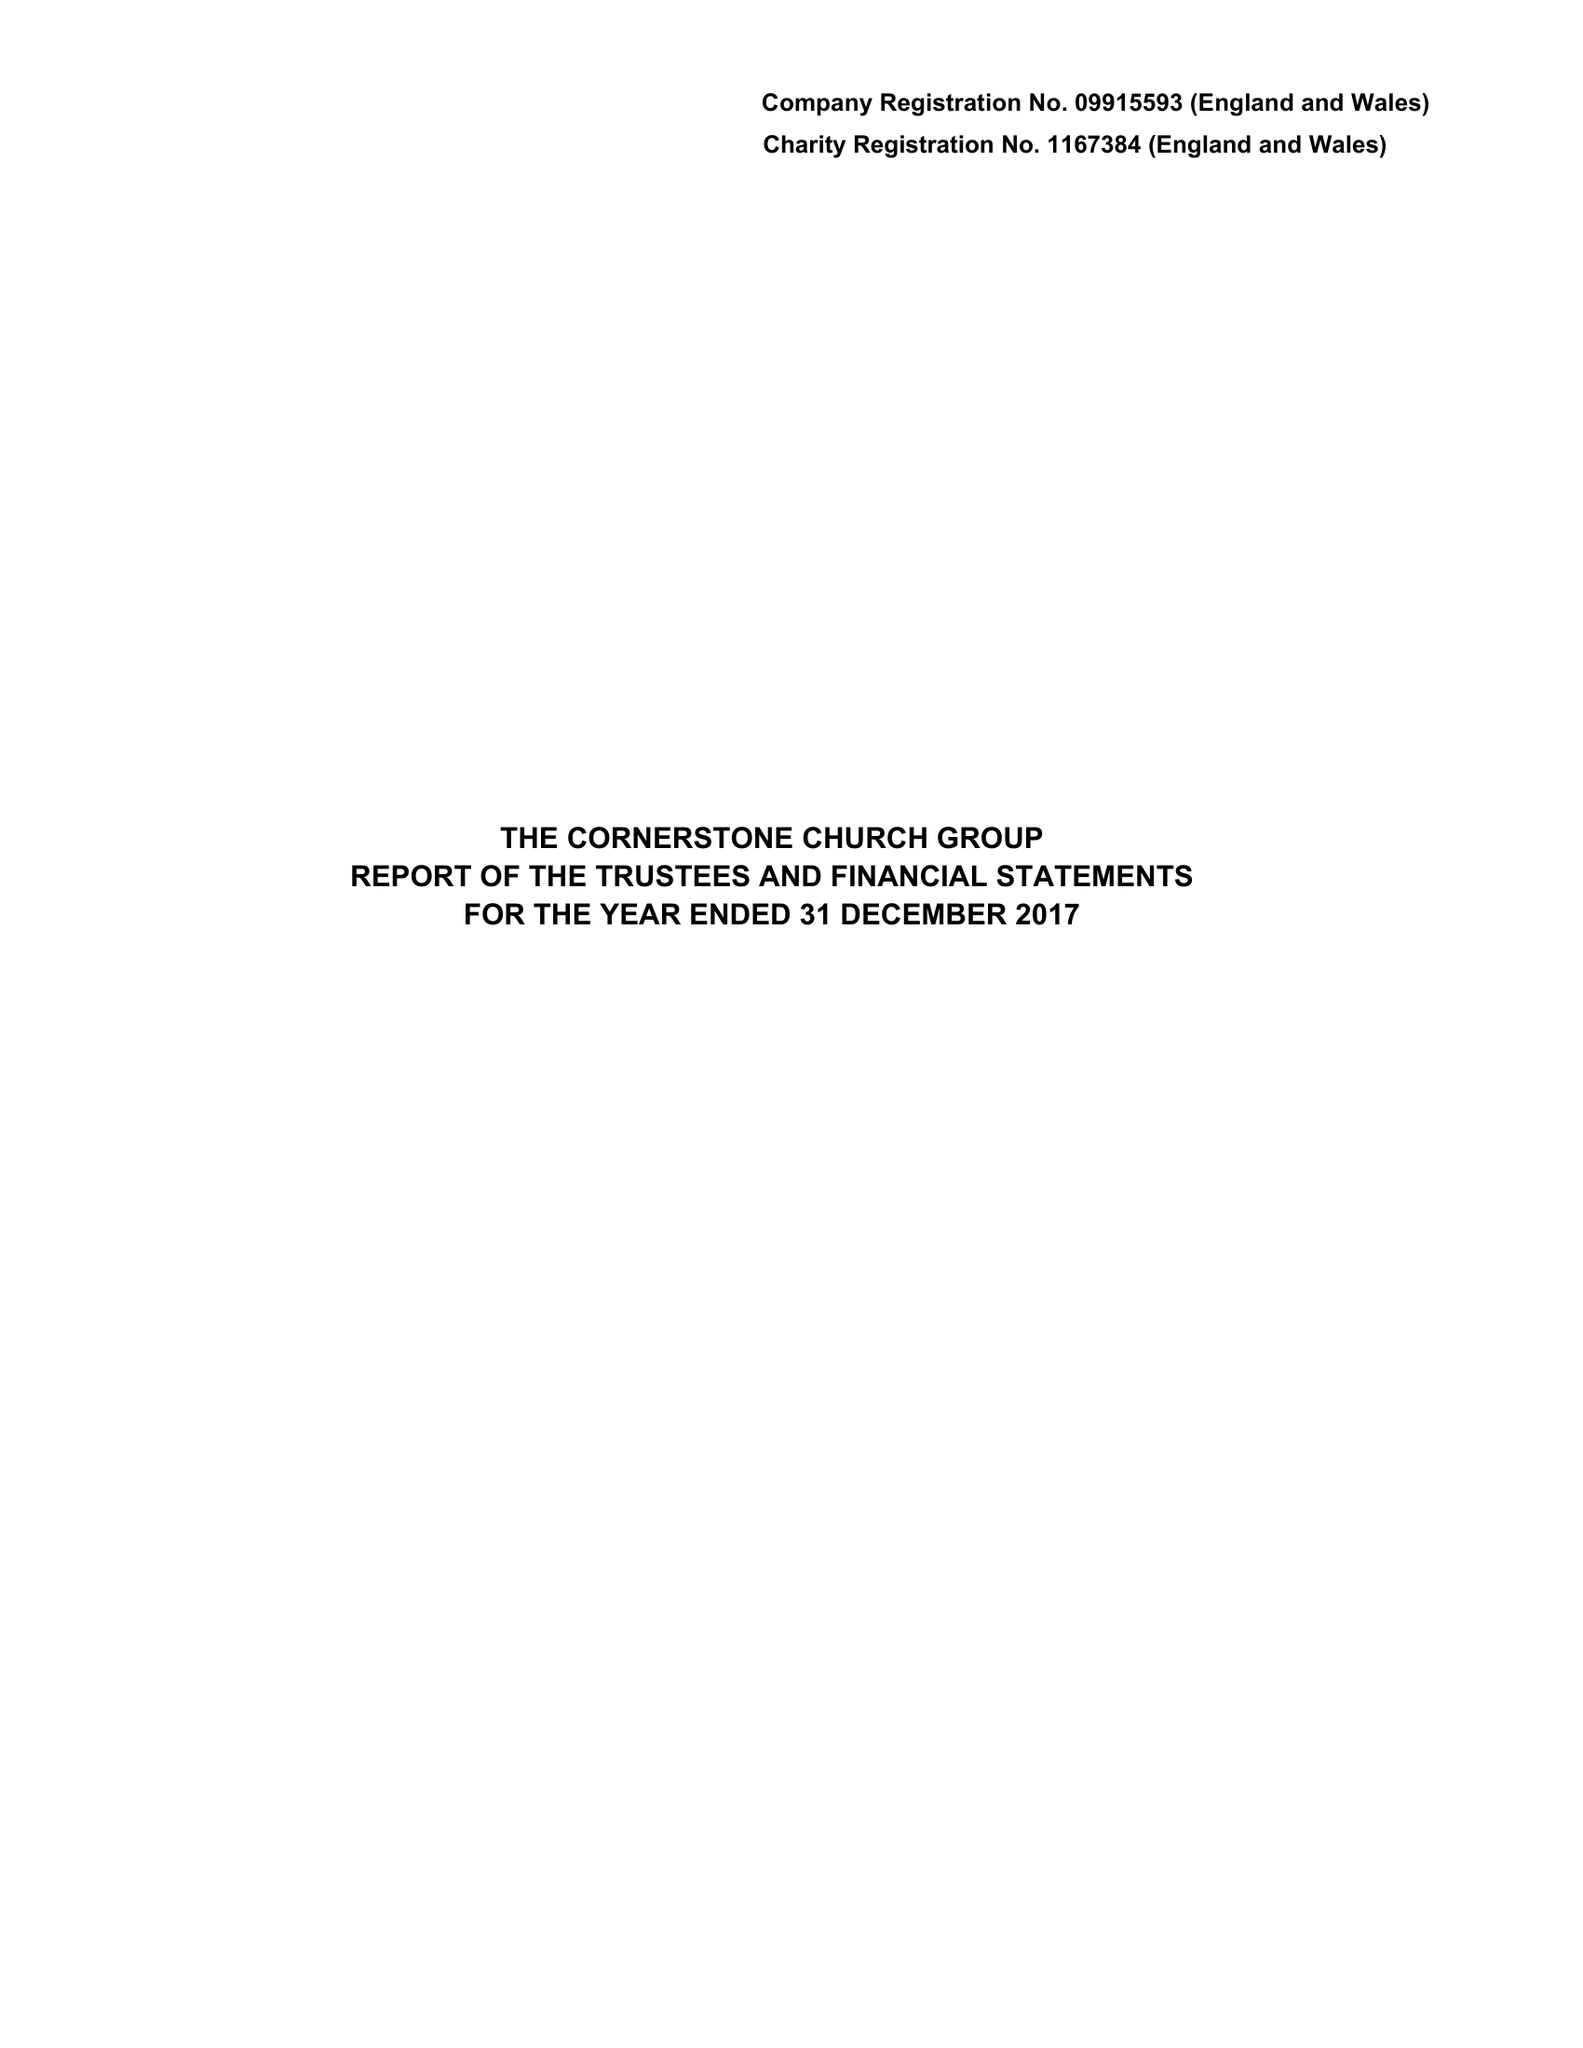What is the value for the address__post_town?
Answer the question using a single word or phrase. LONDON 